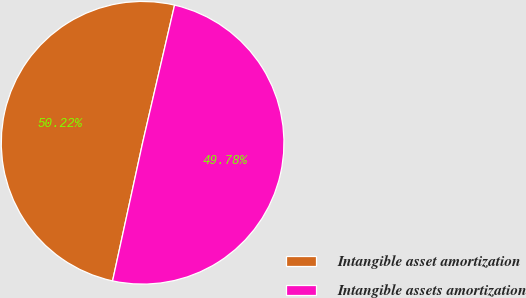Convert chart to OTSL. <chart><loc_0><loc_0><loc_500><loc_500><pie_chart><fcel>Intangible asset amortization<fcel>Intangible assets amortization<nl><fcel>50.22%<fcel>49.78%<nl></chart> 